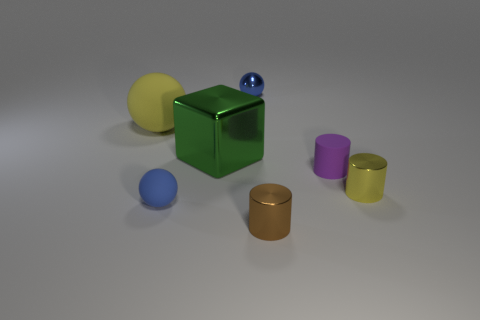Is there any other thing that is the same shape as the green shiny thing?
Keep it short and to the point. No. Is the material of the yellow ball the same as the big block?
Your answer should be very brief. No. What color is the tiny matte thing that is the same shape as the yellow shiny object?
Ensure brevity in your answer.  Purple. Is the color of the small shiny cylinder on the right side of the tiny purple cylinder the same as the metallic block?
Offer a terse response. No. What shape is the thing that is the same color as the small matte sphere?
Your answer should be compact. Sphere. How many small brown things are the same material as the big yellow sphere?
Give a very brief answer. 0. There is a tiny blue matte object; what number of yellow things are on the left side of it?
Keep it short and to the point. 1. What is the size of the blue metal sphere?
Ensure brevity in your answer.  Small. There is a matte ball that is the same size as the brown cylinder; what is its color?
Give a very brief answer. Blue. Are there any large matte balls of the same color as the large rubber object?
Provide a succinct answer. No. 